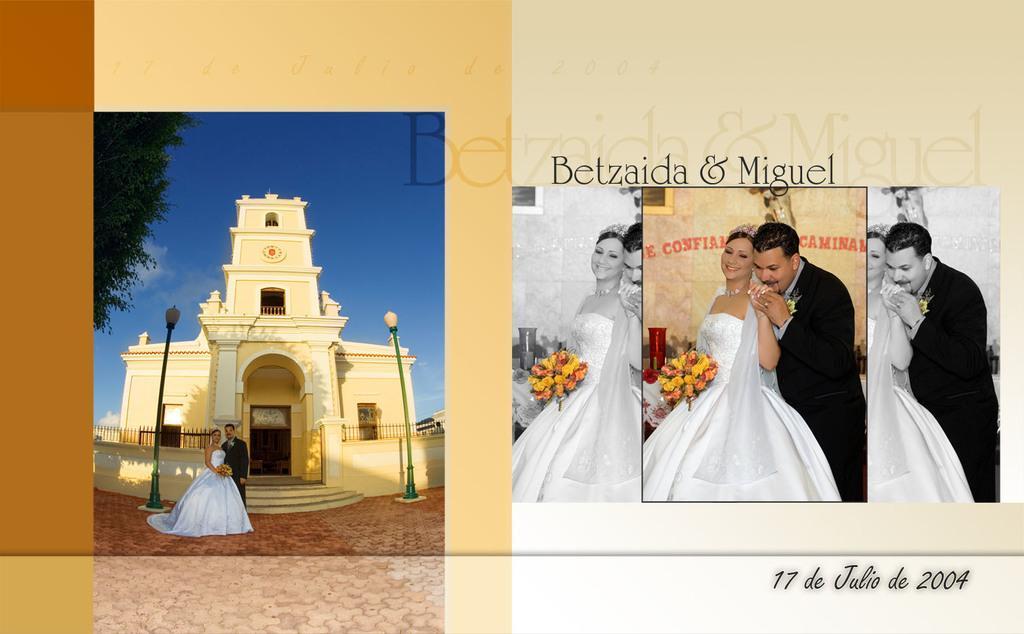Please provide a concise description of this image. This is an edited image. I can see the woman and the man standing in front of the building. These are the streetlights. This is the door. This looks like a tree. I can see the woman holding a flower bouquet in her hand. Here I can see the man holding the woman's hand and kissing. These are the watermarks on the image. 